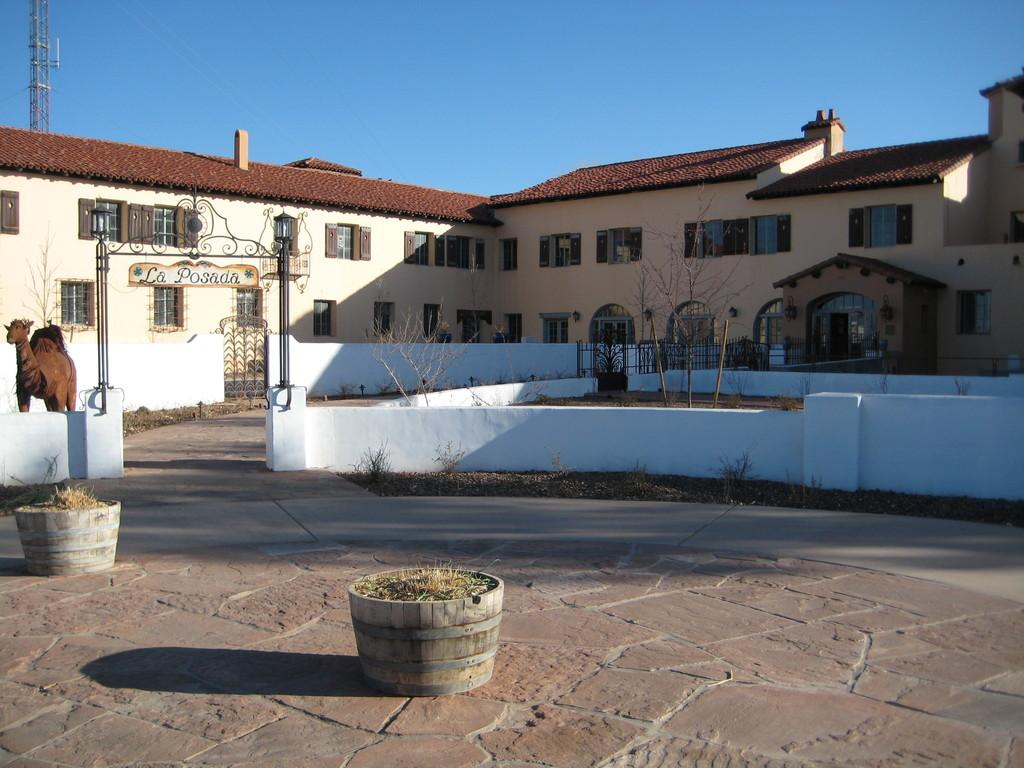What type of structure can be seen in the image? There is a building in the image. What other natural elements are present in the image? There are trees in the image. Are there any animals visible in the image? Yes, there is a camel in the image. What is the purpose of the name board in the image? The name board in the image provides information or identification about the building or location. What other architectural feature can be seen in the image? There is a tower in the image. What is the color of the sky in the image? The sky is blue in the image. Can you tell me how many lifts are available in the building in the image? There is no information about the number of lifts in the building in the image. What type of carriage is being pulled by the camel in the image? There is no carriage being pulled by the camel in the image. 